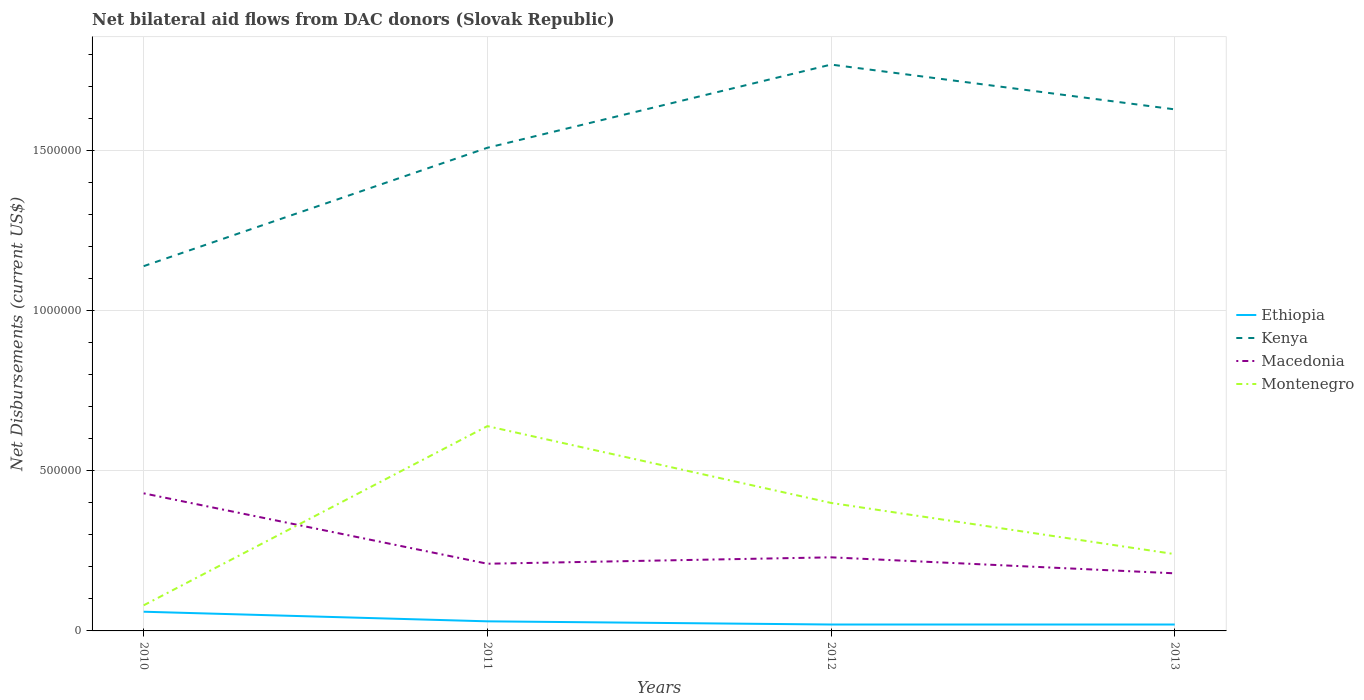Does the line corresponding to Ethiopia intersect with the line corresponding to Montenegro?
Keep it short and to the point. No. Is the number of lines equal to the number of legend labels?
Give a very brief answer. Yes. What is the total net bilateral aid flows in Kenya in the graph?
Offer a terse response. -3.70e+05. What is the difference between the highest and the second highest net bilateral aid flows in Macedonia?
Make the answer very short. 2.50e+05. What is the difference between the highest and the lowest net bilateral aid flows in Ethiopia?
Make the answer very short. 1. How many lines are there?
Keep it short and to the point. 4. How many years are there in the graph?
Your response must be concise. 4. Are the values on the major ticks of Y-axis written in scientific E-notation?
Keep it short and to the point. No. Does the graph contain grids?
Offer a very short reply. Yes. What is the title of the graph?
Provide a succinct answer. Net bilateral aid flows from DAC donors (Slovak Republic). Does "United States" appear as one of the legend labels in the graph?
Give a very brief answer. No. What is the label or title of the X-axis?
Your answer should be compact. Years. What is the label or title of the Y-axis?
Provide a short and direct response. Net Disbursements (current US$). What is the Net Disbursements (current US$) in Ethiopia in 2010?
Offer a terse response. 6.00e+04. What is the Net Disbursements (current US$) of Kenya in 2010?
Offer a terse response. 1.14e+06. What is the Net Disbursements (current US$) of Ethiopia in 2011?
Offer a very short reply. 3.00e+04. What is the Net Disbursements (current US$) in Kenya in 2011?
Offer a very short reply. 1.51e+06. What is the Net Disbursements (current US$) of Montenegro in 2011?
Provide a succinct answer. 6.40e+05. What is the Net Disbursements (current US$) in Ethiopia in 2012?
Your answer should be compact. 2.00e+04. What is the Net Disbursements (current US$) in Kenya in 2012?
Keep it short and to the point. 1.77e+06. What is the Net Disbursements (current US$) in Kenya in 2013?
Your response must be concise. 1.63e+06. Across all years, what is the maximum Net Disbursements (current US$) of Ethiopia?
Provide a short and direct response. 6.00e+04. Across all years, what is the maximum Net Disbursements (current US$) of Kenya?
Provide a short and direct response. 1.77e+06. Across all years, what is the maximum Net Disbursements (current US$) of Macedonia?
Make the answer very short. 4.30e+05. Across all years, what is the maximum Net Disbursements (current US$) of Montenegro?
Offer a terse response. 6.40e+05. Across all years, what is the minimum Net Disbursements (current US$) in Ethiopia?
Offer a very short reply. 2.00e+04. Across all years, what is the minimum Net Disbursements (current US$) of Kenya?
Offer a terse response. 1.14e+06. Across all years, what is the minimum Net Disbursements (current US$) in Macedonia?
Offer a very short reply. 1.80e+05. Across all years, what is the minimum Net Disbursements (current US$) in Montenegro?
Ensure brevity in your answer.  8.00e+04. What is the total Net Disbursements (current US$) in Ethiopia in the graph?
Your answer should be compact. 1.30e+05. What is the total Net Disbursements (current US$) of Kenya in the graph?
Keep it short and to the point. 6.05e+06. What is the total Net Disbursements (current US$) of Macedonia in the graph?
Provide a short and direct response. 1.05e+06. What is the total Net Disbursements (current US$) in Montenegro in the graph?
Your answer should be compact. 1.36e+06. What is the difference between the Net Disbursements (current US$) in Ethiopia in 2010 and that in 2011?
Your response must be concise. 3.00e+04. What is the difference between the Net Disbursements (current US$) of Kenya in 2010 and that in 2011?
Make the answer very short. -3.70e+05. What is the difference between the Net Disbursements (current US$) in Macedonia in 2010 and that in 2011?
Give a very brief answer. 2.20e+05. What is the difference between the Net Disbursements (current US$) of Montenegro in 2010 and that in 2011?
Offer a very short reply. -5.60e+05. What is the difference between the Net Disbursements (current US$) of Ethiopia in 2010 and that in 2012?
Make the answer very short. 4.00e+04. What is the difference between the Net Disbursements (current US$) of Kenya in 2010 and that in 2012?
Keep it short and to the point. -6.30e+05. What is the difference between the Net Disbursements (current US$) in Montenegro in 2010 and that in 2012?
Give a very brief answer. -3.20e+05. What is the difference between the Net Disbursements (current US$) in Kenya in 2010 and that in 2013?
Give a very brief answer. -4.90e+05. What is the difference between the Net Disbursements (current US$) of Kenya in 2011 and that in 2012?
Your answer should be very brief. -2.60e+05. What is the difference between the Net Disbursements (current US$) in Montenegro in 2011 and that in 2012?
Give a very brief answer. 2.40e+05. What is the difference between the Net Disbursements (current US$) of Ethiopia in 2011 and that in 2013?
Your response must be concise. 10000. What is the difference between the Net Disbursements (current US$) in Kenya in 2011 and that in 2013?
Ensure brevity in your answer.  -1.20e+05. What is the difference between the Net Disbursements (current US$) of Kenya in 2012 and that in 2013?
Your answer should be compact. 1.40e+05. What is the difference between the Net Disbursements (current US$) in Ethiopia in 2010 and the Net Disbursements (current US$) in Kenya in 2011?
Provide a short and direct response. -1.45e+06. What is the difference between the Net Disbursements (current US$) of Ethiopia in 2010 and the Net Disbursements (current US$) of Montenegro in 2011?
Offer a terse response. -5.80e+05. What is the difference between the Net Disbursements (current US$) of Kenya in 2010 and the Net Disbursements (current US$) of Macedonia in 2011?
Your answer should be very brief. 9.30e+05. What is the difference between the Net Disbursements (current US$) of Kenya in 2010 and the Net Disbursements (current US$) of Montenegro in 2011?
Provide a succinct answer. 5.00e+05. What is the difference between the Net Disbursements (current US$) in Macedonia in 2010 and the Net Disbursements (current US$) in Montenegro in 2011?
Provide a short and direct response. -2.10e+05. What is the difference between the Net Disbursements (current US$) in Ethiopia in 2010 and the Net Disbursements (current US$) in Kenya in 2012?
Provide a short and direct response. -1.71e+06. What is the difference between the Net Disbursements (current US$) of Ethiopia in 2010 and the Net Disbursements (current US$) of Montenegro in 2012?
Provide a short and direct response. -3.40e+05. What is the difference between the Net Disbursements (current US$) in Kenya in 2010 and the Net Disbursements (current US$) in Macedonia in 2012?
Keep it short and to the point. 9.10e+05. What is the difference between the Net Disbursements (current US$) of Kenya in 2010 and the Net Disbursements (current US$) of Montenegro in 2012?
Ensure brevity in your answer.  7.40e+05. What is the difference between the Net Disbursements (current US$) of Ethiopia in 2010 and the Net Disbursements (current US$) of Kenya in 2013?
Your response must be concise. -1.57e+06. What is the difference between the Net Disbursements (current US$) in Kenya in 2010 and the Net Disbursements (current US$) in Macedonia in 2013?
Provide a succinct answer. 9.60e+05. What is the difference between the Net Disbursements (current US$) of Ethiopia in 2011 and the Net Disbursements (current US$) of Kenya in 2012?
Your response must be concise. -1.74e+06. What is the difference between the Net Disbursements (current US$) of Ethiopia in 2011 and the Net Disbursements (current US$) of Montenegro in 2012?
Ensure brevity in your answer.  -3.70e+05. What is the difference between the Net Disbursements (current US$) of Kenya in 2011 and the Net Disbursements (current US$) of Macedonia in 2012?
Provide a short and direct response. 1.28e+06. What is the difference between the Net Disbursements (current US$) of Kenya in 2011 and the Net Disbursements (current US$) of Montenegro in 2012?
Offer a very short reply. 1.11e+06. What is the difference between the Net Disbursements (current US$) in Ethiopia in 2011 and the Net Disbursements (current US$) in Kenya in 2013?
Provide a succinct answer. -1.60e+06. What is the difference between the Net Disbursements (current US$) of Ethiopia in 2011 and the Net Disbursements (current US$) of Macedonia in 2013?
Your response must be concise. -1.50e+05. What is the difference between the Net Disbursements (current US$) in Kenya in 2011 and the Net Disbursements (current US$) in Macedonia in 2013?
Ensure brevity in your answer.  1.33e+06. What is the difference between the Net Disbursements (current US$) in Kenya in 2011 and the Net Disbursements (current US$) in Montenegro in 2013?
Offer a terse response. 1.27e+06. What is the difference between the Net Disbursements (current US$) of Ethiopia in 2012 and the Net Disbursements (current US$) of Kenya in 2013?
Keep it short and to the point. -1.61e+06. What is the difference between the Net Disbursements (current US$) of Ethiopia in 2012 and the Net Disbursements (current US$) of Macedonia in 2013?
Your answer should be compact. -1.60e+05. What is the difference between the Net Disbursements (current US$) of Kenya in 2012 and the Net Disbursements (current US$) of Macedonia in 2013?
Ensure brevity in your answer.  1.59e+06. What is the difference between the Net Disbursements (current US$) in Kenya in 2012 and the Net Disbursements (current US$) in Montenegro in 2013?
Provide a short and direct response. 1.53e+06. What is the average Net Disbursements (current US$) of Ethiopia per year?
Offer a terse response. 3.25e+04. What is the average Net Disbursements (current US$) in Kenya per year?
Your answer should be very brief. 1.51e+06. What is the average Net Disbursements (current US$) of Macedonia per year?
Keep it short and to the point. 2.62e+05. In the year 2010, what is the difference between the Net Disbursements (current US$) of Ethiopia and Net Disbursements (current US$) of Kenya?
Offer a very short reply. -1.08e+06. In the year 2010, what is the difference between the Net Disbursements (current US$) in Ethiopia and Net Disbursements (current US$) in Macedonia?
Make the answer very short. -3.70e+05. In the year 2010, what is the difference between the Net Disbursements (current US$) in Kenya and Net Disbursements (current US$) in Macedonia?
Your answer should be compact. 7.10e+05. In the year 2010, what is the difference between the Net Disbursements (current US$) of Kenya and Net Disbursements (current US$) of Montenegro?
Make the answer very short. 1.06e+06. In the year 2010, what is the difference between the Net Disbursements (current US$) in Macedonia and Net Disbursements (current US$) in Montenegro?
Give a very brief answer. 3.50e+05. In the year 2011, what is the difference between the Net Disbursements (current US$) in Ethiopia and Net Disbursements (current US$) in Kenya?
Offer a very short reply. -1.48e+06. In the year 2011, what is the difference between the Net Disbursements (current US$) of Ethiopia and Net Disbursements (current US$) of Macedonia?
Provide a succinct answer. -1.80e+05. In the year 2011, what is the difference between the Net Disbursements (current US$) of Ethiopia and Net Disbursements (current US$) of Montenegro?
Provide a succinct answer. -6.10e+05. In the year 2011, what is the difference between the Net Disbursements (current US$) of Kenya and Net Disbursements (current US$) of Macedonia?
Provide a short and direct response. 1.30e+06. In the year 2011, what is the difference between the Net Disbursements (current US$) in Kenya and Net Disbursements (current US$) in Montenegro?
Offer a terse response. 8.70e+05. In the year 2011, what is the difference between the Net Disbursements (current US$) of Macedonia and Net Disbursements (current US$) of Montenegro?
Provide a succinct answer. -4.30e+05. In the year 2012, what is the difference between the Net Disbursements (current US$) of Ethiopia and Net Disbursements (current US$) of Kenya?
Keep it short and to the point. -1.75e+06. In the year 2012, what is the difference between the Net Disbursements (current US$) in Ethiopia and Net Disbursements (current US$) in Montenegro?
Provide a succinct answer. -3.80e+05. In the year 2012, what is the difference between the Net Disbursements (current US$) of Kenya and Net Disbursements (current US$) of Macedonia?
Keep it short and to the point. 1.54e+06. In the year 2012, what is the difference between the Net Disbursements (current US$) of Kenya and Net Disbursements (current US$) of Montenegro?
Make the answer very short. 1.37e+06. In the year 2013, what is the difference between the Net Disbursements (current US$) in Ethiopia and Net Disbursements (current US$) in Kenya?
Provide a short and direct response. -1.61e+06. In the year 2013, what is the difference between the Net Disbursements (current US$) in Ethiopia and Net Disbursements (current US$) in Montenegro?
Your response must be concise. -2.20e+05. In the year 2013, what is the difference between the Net Disbursements (current US$) in Kenya and Net Disbursements (current US$) in Macedonia?
Make the answer very short. 1.45e+06. In the year 2013, what is the difference between the Net Disbursements (current US$) in Kenya and Net Disbursements (current US$) in Montenegro?
Offer a very short reply. 1.39e+06. In the year 2013, what is the difference between the Net Disbursements (current US$) in Macedonia and Net Disbursements (current US$) in Montenegro?
Make the answer very short. -6.00e+04. What is the ratio of the Net Disbursements (current US$) of Ethiopia in 2010 to that in 2011?
Keep it short and to the point. 2. What is the ratio of the Net Disbursements (current US$) in Kenya in 2010 to that in 2011?
Offer a very short reply. 0.76. What is the ratio of the Net Disbursements (current US$) in Macedonia in 2010 to that in 2011?
Make the answer very short. 2.05. What is the ratio of the Net Disbursements (current US$) of Montenegro in 2010 to that in 2011?
Your answer should be compact. 0.12. What is the ratio of the Net Disbursements (current US$) of Ethiopia in 2010 to that in 2012?
Your answer should be compact. 3. What is the ratio of the Net Disbursements (current US$) of Kenya in 2010 to that in 2012?
Offer a very short reply. 0.64. What is the ratio of the Net Disbursements (current US$) in Macedonia in 2010 to that in 2012?
Ensure brevity in your answer.  1.87. What is the ratio of the Net Disbursements (current US$) in Kenya in 2010 to that in 2013?
Your answer should be compact. 0.7. What is the ratio of the Net Disbursements (current US$) of Macedonia in 2010 to that in 2013?
Your answer should be very brief. 2.39. What is the ratio of the Net Disbursements (current US$) of Montenegro in 2010 to that in 2013?
Your answer should be compact. 0.33. What is the ratio of the Net Disbursements (current US$) of Kenya in 2011 to that in 2012?
Offer a very short reply. 0.85. What is the ratio of the Net Disbursements (current US$) in Montenegro in 2011 to that in 2012?
Offer a terse response. 1.6. What is the ratio of the Net Disbursements (current US$) in Kenya in 2011 to that in 2013?
Provide a succinct answer. 0.93. What is the ratio of the Net Disbursements (current US$) of Macedonia in 2011 to that in 2013?
Provide a succinct answer. 1.17. What is the ratio of the Net Disbursements (current US$) in Montenegro in 2011 to that in 2013?
Ensure brevity in your answer.  2.67. What is the ratio of the Net Disbursements (current US$) of Ethiopia in 2012 to that in 2013?
Your answer should be compact. 1. What is the ratio of the Net Disbursements (current US$) in Kenya in 2012 to that in 2013?
Offer a terse response. 1.09. What is the ratio of the Net Disbursements (current US$) in Macedonia in 2012 to that in 2013?
Give a very brief answer. 1.28. What is the difference between the highest and the second highest Net Disbursements (current US$) of Macedonia?
Give a very brief answer. 2.00e+05. What is the difference between the highest and the lowest Net Disbursements (current US$) of Kenya?
Your answer should be compact. 6.30e+05. What is the difference between the highest and the lowest Net Disbursements (current US$) of Montenegro?
Keep it short and to the point. 5.60e+05. 